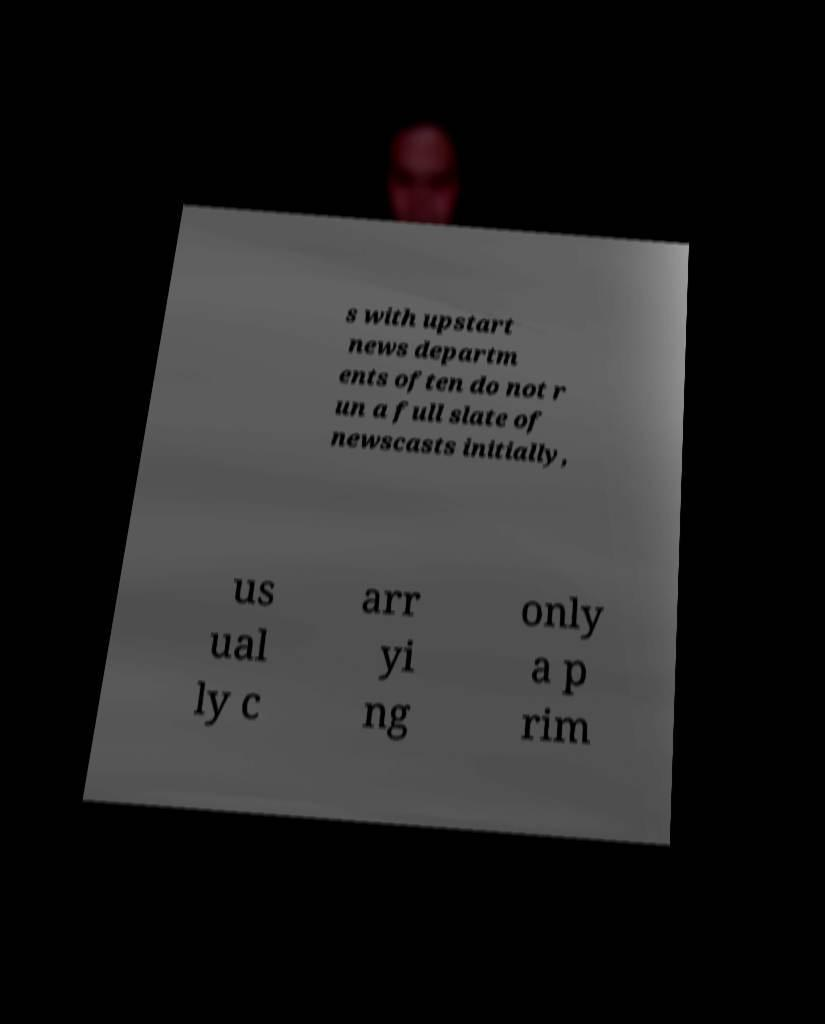Please read and relay the text visible in this image. What does it say? s with upstart news departm ents often do not r un a full slate of newscasts initially, us ual ly c arr yi ng only a p rim 